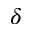Convert formula to latex. <formula><loc_0><loc_0><loc_500><loc_500>\delta</formula> 